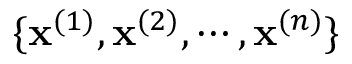<formula> <loc_0><loc_0><loc_500><loc_500>\{ x ^ { ( 1 ) } , x ^ { ( 2 ) } , \cdots , x ^ { ( n ) } \}</formula> 